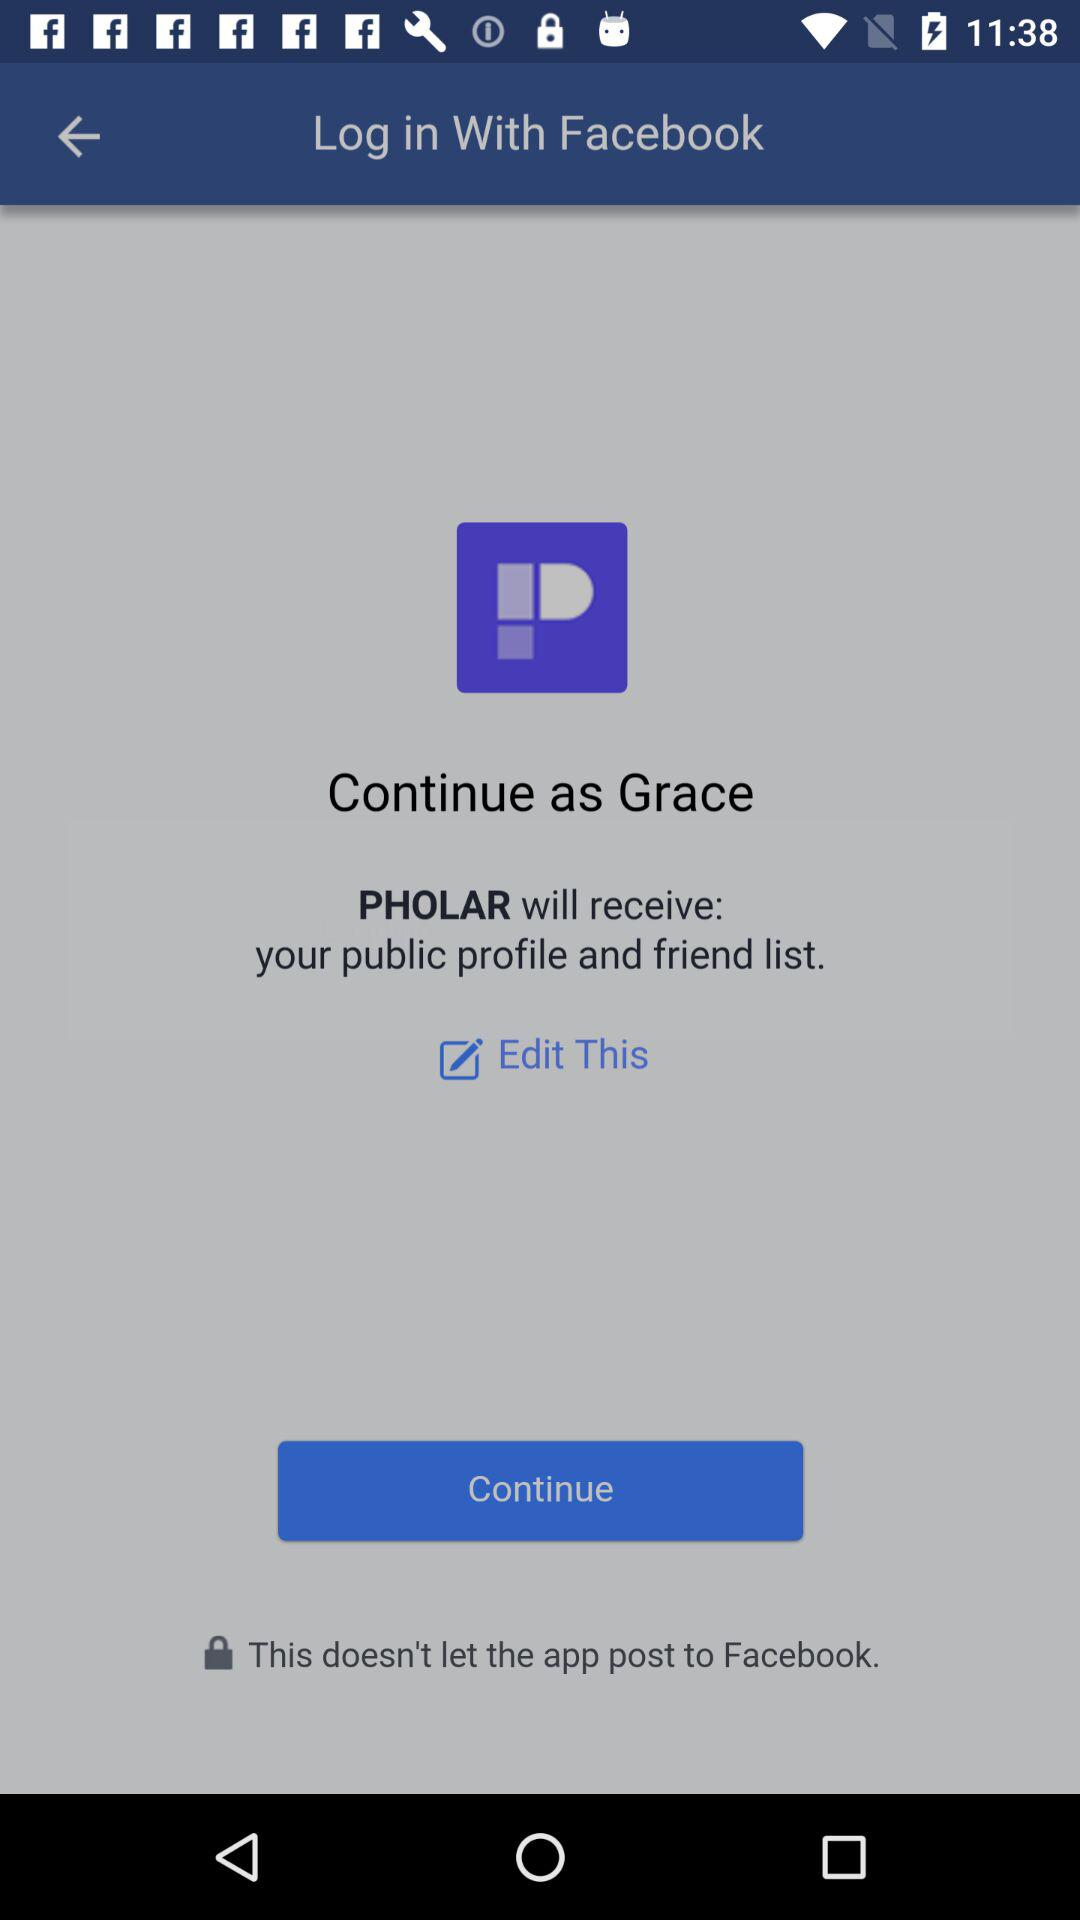What is the name of the user? The name of the user is Grace. 